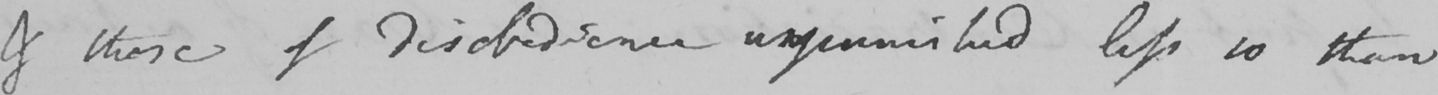What does this handwritten line say? & those of disobedience unpunished less so than 